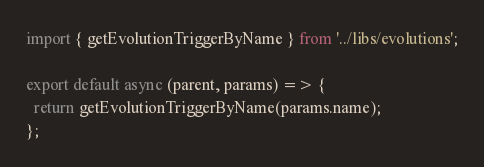Convert code to text. <code><loc_0><loc_0><loc_500><loc_500><_JavaScript_>import { getEvolutionTriggerByName } from '../libs/evolutions';

export default async (parent, params) => {
  return getEvolutionTriggerByName(params.name);
};
</code> 